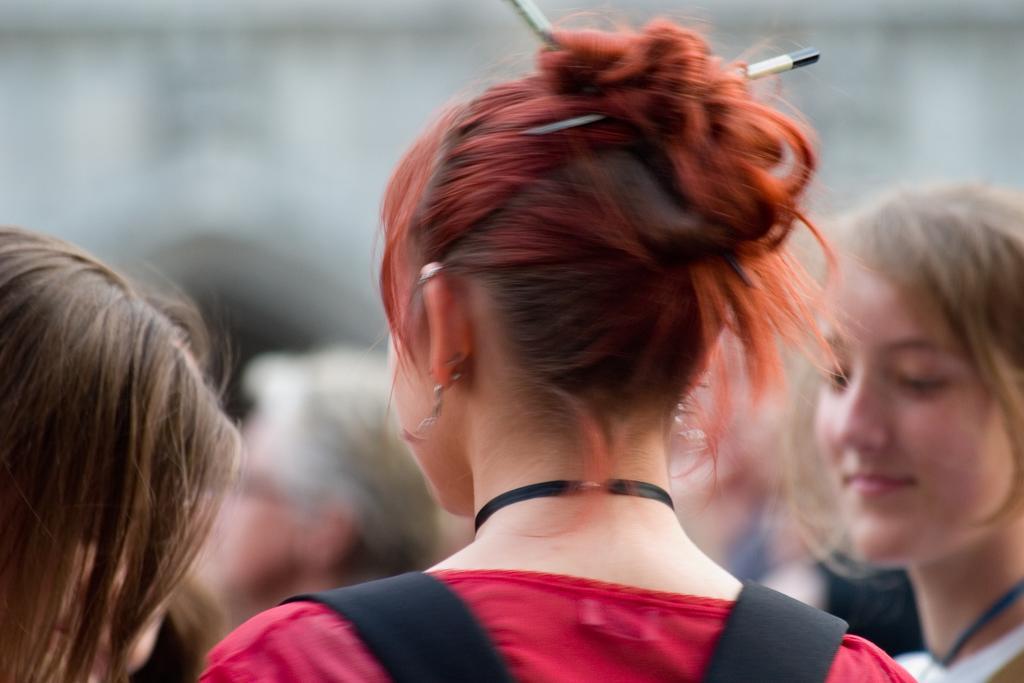Describe this image in one or two sentences. In this image I can see group of people. In front the person is wearing red color dress and I can see the blurred background. 